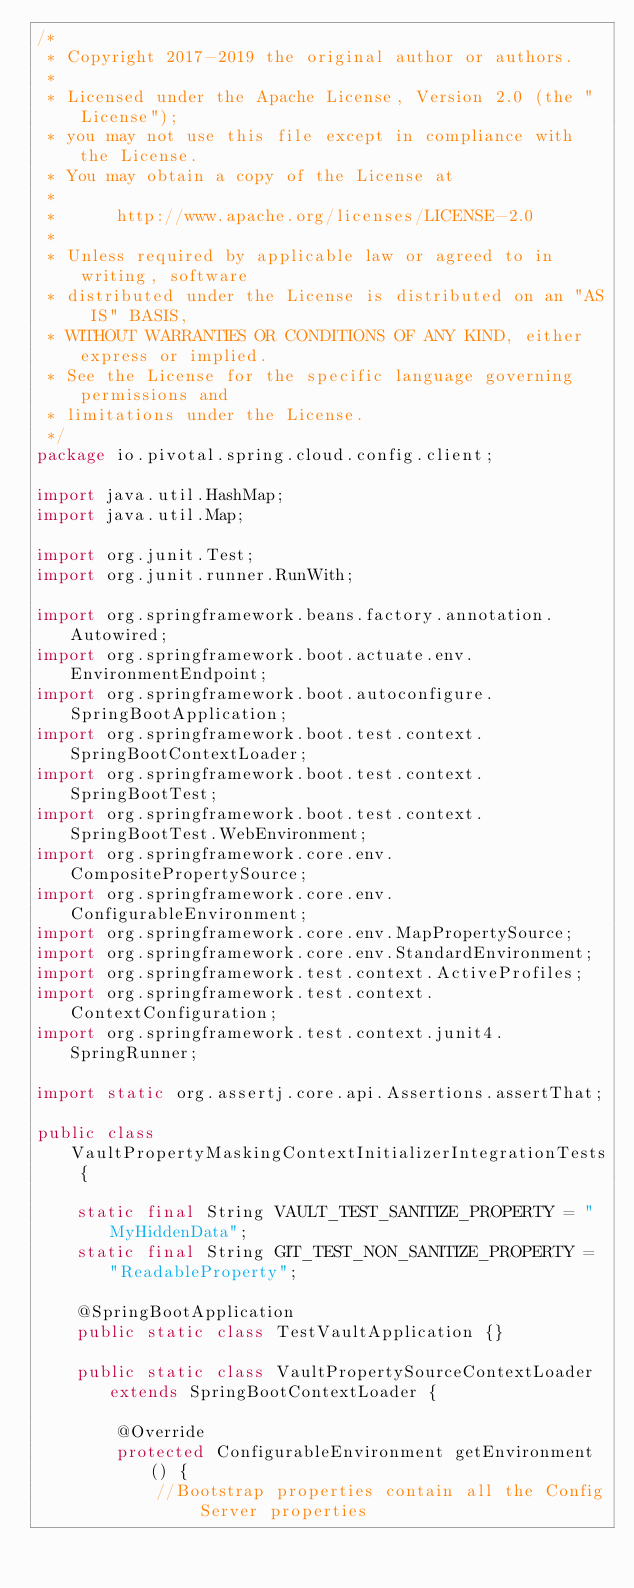Convert code to text. <code><loc_0><loc_0><loc_500><loc_500><_Java_>/*
 * Copyright 2017-2019 the original author or authors.
 *
 * Licensed under the Apache License, Version 2.0 (the "License");
 * you may not use this file except in compliance with the License.
 * You may obtain a copy of the License at
 *
 *      http://www.apache.org/licenses/LICENSE-2.0
 *
 * Unless required by applicable law or agreed to in writing, software
 * distributed under the License is distributed on an "AS IS" BASIS,
 * WITHOUT WARRANTIES OR CONDITIONS OF ANY KIND, either express or implied.
 * See the License for the specific language governing permissions and
 * limitations under the License.
 */
package io.pivotal.spring.cloud.config.client;

import java.util.HashMap;
import java.util.Map;

import org.junit.Test;
import org.junit.runner.RunWith;

import org.springframework.beans.factory.annotation.Autowired;
import org.springframework.boot.actuate.env.EnvironmentEndpoint;
import org.springframework.boot.autoconfigure.SpringBootApplication;
import org.springframework.boot.test.context.SpringBootContextLoader;
import org.springframework.boot.test.context.SpringBootTest;
import org.springframework.boot.test.context.SpringBootTest.WebEnvironment;
import org.springframework.core.env.CompositePropertySource;
import org.springframework.core.env.ConfigurableEnvironment;
import org.springframework.core.env.MapPropertySource;
import org.springframework.core.env.StandardEnvironment;
import org.springframework.test.context.ActiveProfiles;
import org.springframework.test.context.ContextConfiguration;
import org.springframework.test.context.junit4.SpringRunner;

import static org.assertj.core.api.Assertions.assertThat;

public class VaultPropertyMaskingContextInitializerIntegrationTests {

	static final String VAULT_TEST_SANITIZE_PROPERTY = "MyHiddenData";
	static final String GIT_TEST_NON_SANITIZE_PROPERTY = "ReadableProperty";

	@SpringBootApplication
	public static class TestVaultApplication {}

	public static class VaultPropertySourceContextLoader extends SpringBootContextLoader {

		@Override
		protected ConfigurableEnvironment getEnvironment() {
			//Bootstrap properties contain all the Config Server properties</code> 